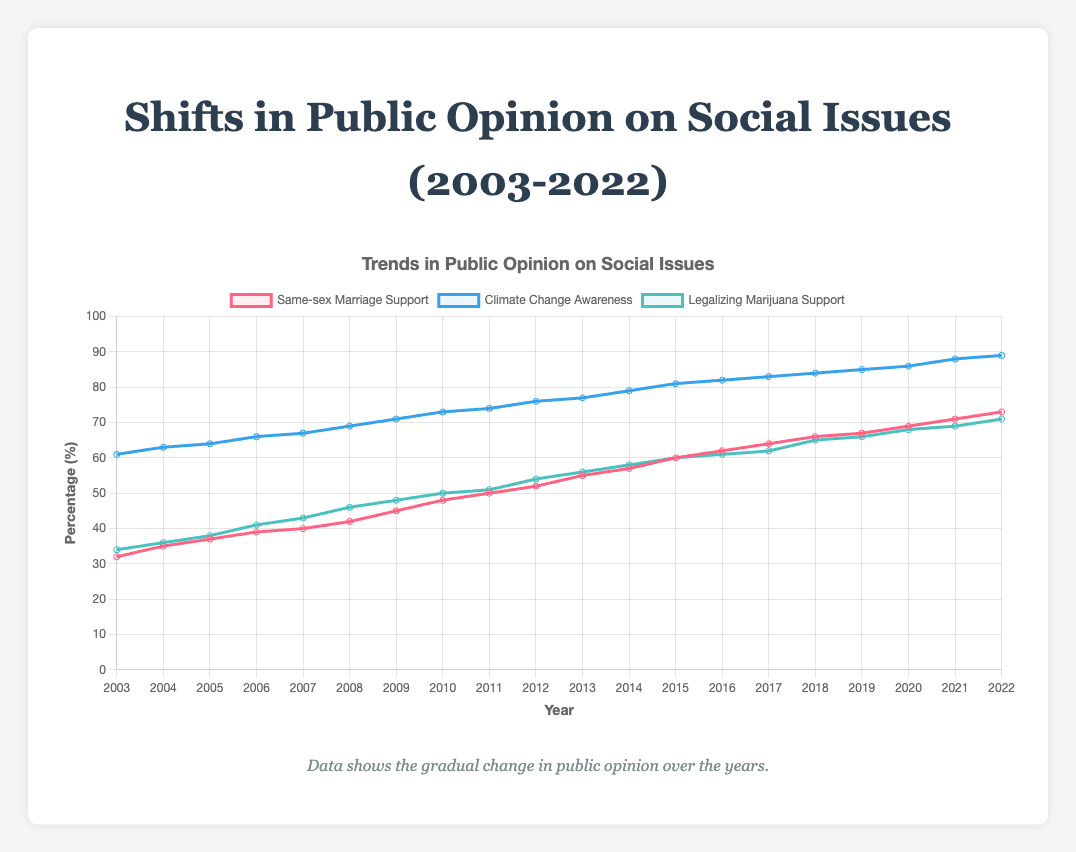What is the trend in climate change awareness from 2003 to 2022? The climate change awareness shows a consistent increase from 61% in 2003 to 89% in 2022. Each year, the percentage either remains the same or increases by a small amount.
Answer: Consistent increase Which year had equal support for same-sex marriage and the awareness of climate change, if any? Analyzing the figure, there is no year where the support for same-sex marriage and climate change awareness are equal. They always differ by some value.
Answer: None By how much did the support for legalizing marijuana change from the year 2003 to 2012? The support for legalizing marijuana in 2003 was 34%, and in 2012, it was 54%. The change is calculated as 54% - 34% = 20%.
Answer: 20% How did the support for same-sex marriage compare to climate change awareness in 2015? In 2015, the support for same-sex marriage was 60%, and climate change awareness was 81%. Climate change awareness was higher than same-sex marriage support by 81% - 60% = 21%.
Answer: 21% During which years was the support for legalizing marijuana greater than 50%? The years with support for legalizing marijuana greater than 50% were 2013 and beyond, starting from 56% in 2013 up to 71% in 2022.
Answer: 2013-2022 What was the average support for same-sex marriage over the first five years (2003-2007)? Over the first five years, the support levels were 32%, 35%, 37%, 39%, and 40%. The average is (32 + 35 + 37 + 39 + 40) / 5 = 36.6%.
Answer: 36.6% Which social issue showed the highest level of support in 2022? In 2022, climate change awareness had the highest level of support at 89%, compared to 73% for same-sex marriage support and 71% for legalizing marijuana support.
Answer: Climate change awareness What is the median percentage of support for legalizing marijuana from 2010 to 2017? The data points from 2010 to 2017 are 50%, 51%, 54%, 56%, 58%, 60%, 61%, and 62%. When these values are ordered, the median is the middle value. Since there are 8 values, the median is the average of the 4th and 5th values: (56 + 58) / 2 = 57%.
Answer: 57% Compare the increase in support for same-sex marriage between 2008 to 2012 with the increase from 2015 to 2019. Which period had a greater increase? From 2008 to 2012, support increased from 42% to 52%, an increase of 10%. From 2015 to 2019, support increased from 60% to 67%, an increase of 7%. The earlier period had a greater increase.
Answer: 2008-2012 What were the trends in public opinion over 20 years for same-sex marriage, climate change, and legalizing marijuana? All three social issues showed an upward trend in public support over the 20 years. Same-sex marriage support rose from 32% to 73%, climate change awareness increased from 61% to 89%, and support for legalizing marijuana went from 34% to 71%.
Answer: Upward trend for all 